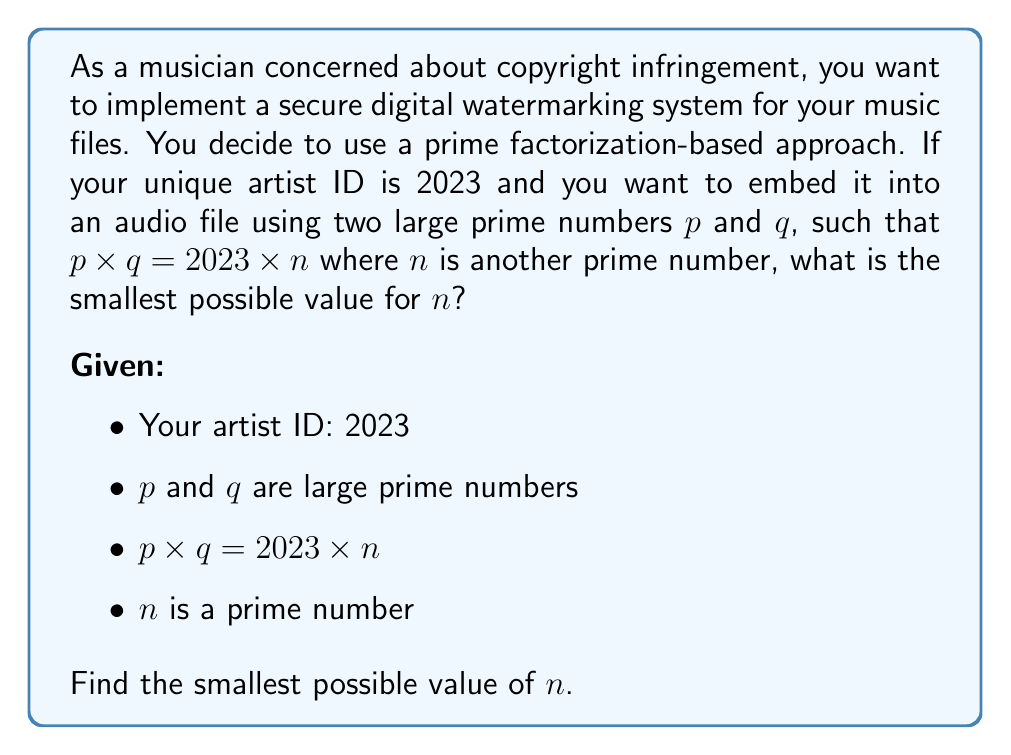Solve this math problem. To solve this problem, we'll follow these steps:

1) First, we need to factorize 2023:
   $2023 = 7 \times 17 \times 17$

2) Now, we're looking for two large primes $p$ and $q$ such that their product is divisible by 2023. The smallest such product would be 2023 itself multiplied by the next prime number larger than any of its factors.

3) The largest factor of 2023 is 17, so we need to find the next prime number after 17.

4) The prime numbers after 17 are: 19, 23, 29, 31, 37, ...

5) We need to check if any of these, when multiplied by 2023, results in a product that can be factored into two large primes.

6) Let's start with 19:
   $2023 \times 19 = 38437$

7) We need to check if 38437 can be factored into two large primes. Using a factorization calculator, we find:
   $38437 = 191 \times 201$

8) 191 is prime, but 201 is not (201 = 3 × 67). So 19 is not our answer.

9) Let's try the next prime, 23:
   $2023 \times 23 = 46529$

10) Factoring 46529, we get:
    $46529 = 191 \times 243$

11) Again, 191 is prime, but 243 is not. So 23 is not our answer.

12) The next prime is 29:
    $2023 \times 29 = 58667$

13) Factoring 58667, we get:
    $58667 = 241 \times 243$

14) 241 is prime, but 243 is not. So 29 is not our answer.

15) Let's try 31:
    $2023 \times 31 = 62713$

16) Factoring 62713, we get:
    $62713 = 251 \times 249$

17) 251 is prime, but 249 is not. So 31 is not our answer.

18) The next prime is 37:
    $2023 \times 37 = 74851$

19) Factoring 74851, we get:
    $74851 = 263 \times 283$

20) Both 263 and 283 are prime numbers! We have found our answer.

Therefore, the smallest value of $n$ that satisfies the conditions is 37.
Answer: 37 